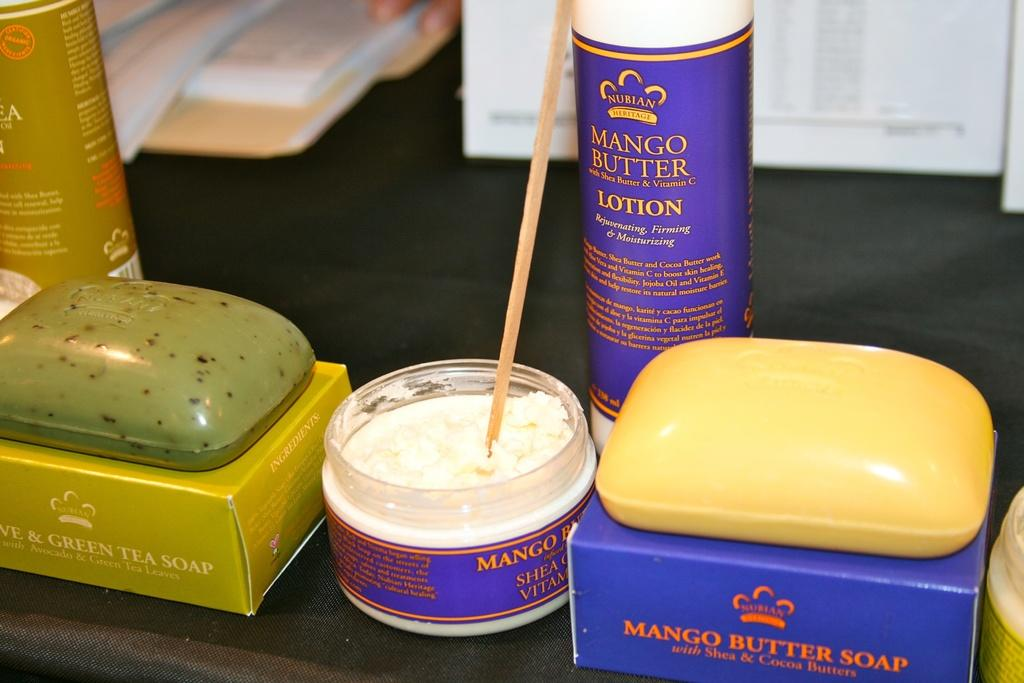<image>
Offer a succinct explanation of the picture presented. On a table lies a bottle of Mango butter lotion and a bar of Mango butter soap. 